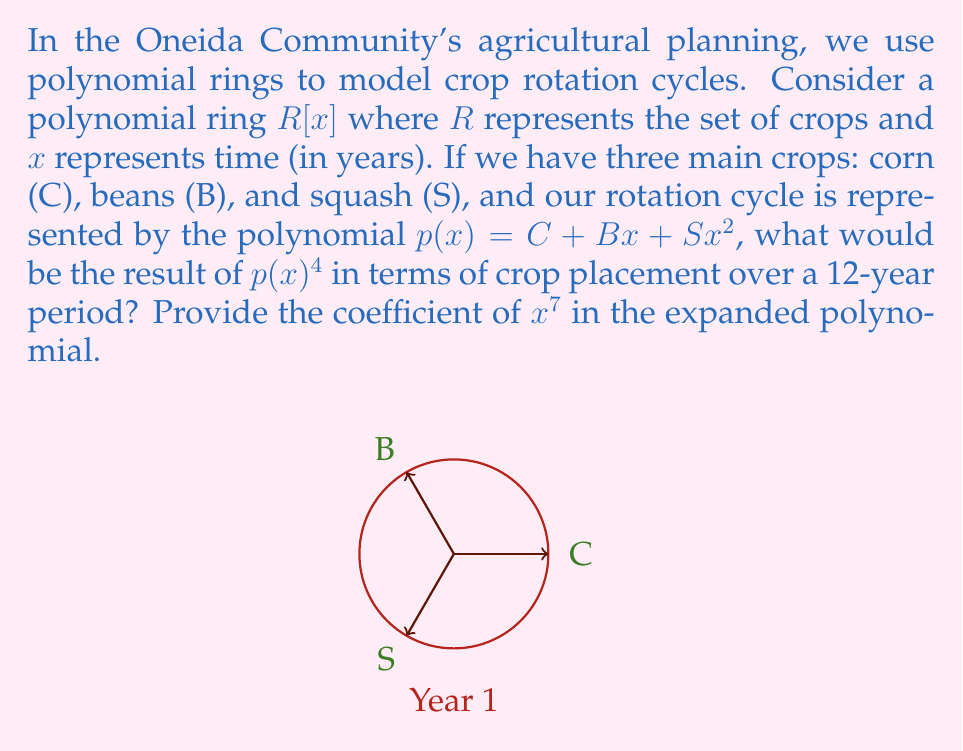Teach me how to tackle this problem. Let's approach this step-by-step:

1) First, we need to understand what $p(x)^4$ represents. It's the rotation cycle repeated 4 times, covering a 12-year period.

2) To expand $p(x)^4$, we use the binomial theorem:

   $p(x)^4 = (C + Bx + Sx^2)^4$

3) Expanding this fully would be complex, so let's focus on finding the coefficient of $x^7$.

4) The terms that could contribute to $x^7$ are:
   - $C \cdot (Bx)^3 \cdot (Sx^2)^1$
   - $C \cdot (Bx)^1 \cdot (Sx^2)^3$

5) Let's calculate these:
   - $C \cdot (Bx)^3 \cdot (Sx^2)^1 = CB^3Sx^7$
   - $C \cdot (Bx)^1 \cdot (Sx^2)^3 = CBS^3x^7$

6) Now, we need to consider the coefficients from the binomial expansion:
   - For $CB^3Sx^7$, we choose 1 S, 3 B, and 1 C from 4 terms: $\binom{4}{1,3,1} = \frac{4!}{1!3!1!} = 4$
   - For $CBS^3x^7$, we choose 3 S, 1 B, and 1 C from 4 terms: $\binom{4}{3,1,1} = \frac{4!}{3!1!1!} = 4$

7) Therefore, the coefficient of $x^7$ is:

   $4CB^3S + 4CBS^3$

This coefficient represents the number of ways each crop combination appears in year 8 of the 12-year cycle.
Answer: $4CB^3S + 4CBS^3$ 